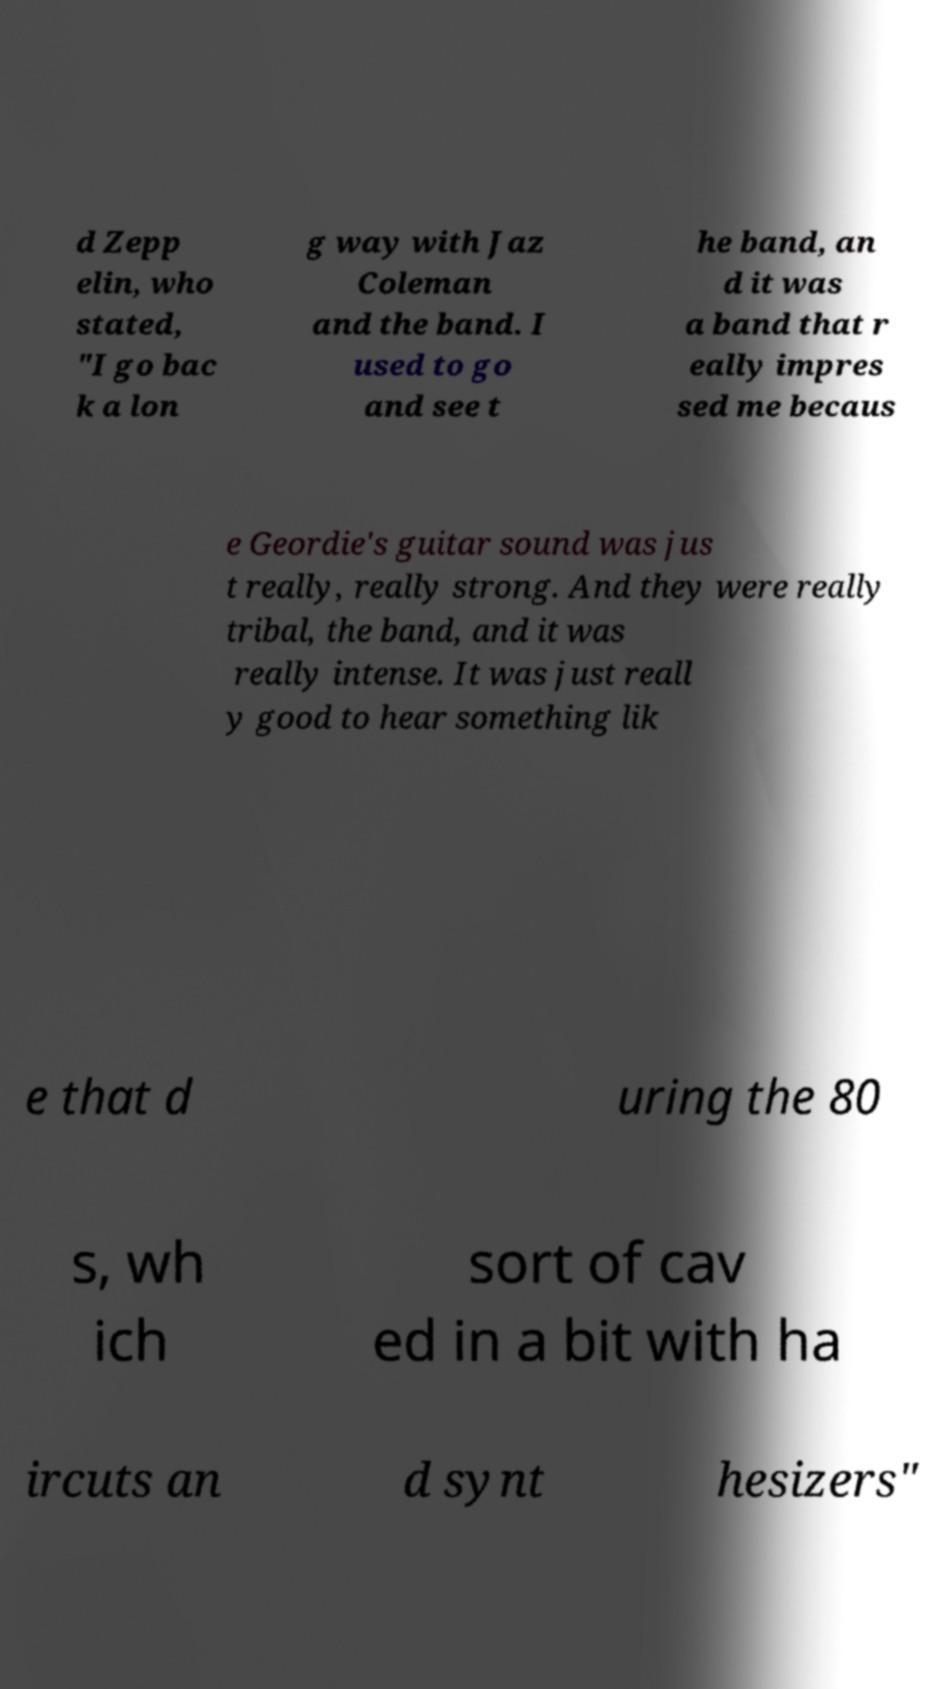For documentation purposes, I need the text within this image transcribed. Could you provide that? d Zepp elin, who stated, "I go bac k a lon g way with Jaz Coleman and the band. I used to go and see t he band, an d it was a band that r eally impres sed me becaus e Geordie's guitar sound was jus t really, really strong. And they were really tribal, the band, and it was really intense. It was just reall y good to hear something lik e that d uring the 80 s, wh ich sort of cav ed in a bit with ha ircuts an d synt hesizers" 